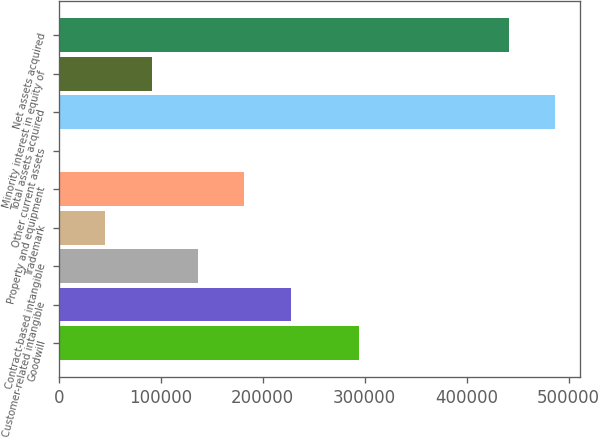<chart> <loc_0><loc_0><loc_500><loc_500><bar_chart><fcel>Goodwill<fcel>Customer-related intangible<fcel>Contract-based intangible<fcel>Trademark<fcel>Property and equipment<fcel>Other current assets<fcel>Total assets acquired<fcel>Minority interest in equity of<fcel>Net assets acquired<nl><fcel>294741<fcel>227228<fcel>136377<fcel>45525.7<fcel>181803<fcel>100<fcel>486526<fcel>90951.4<fcel>441100<nl></chart> 